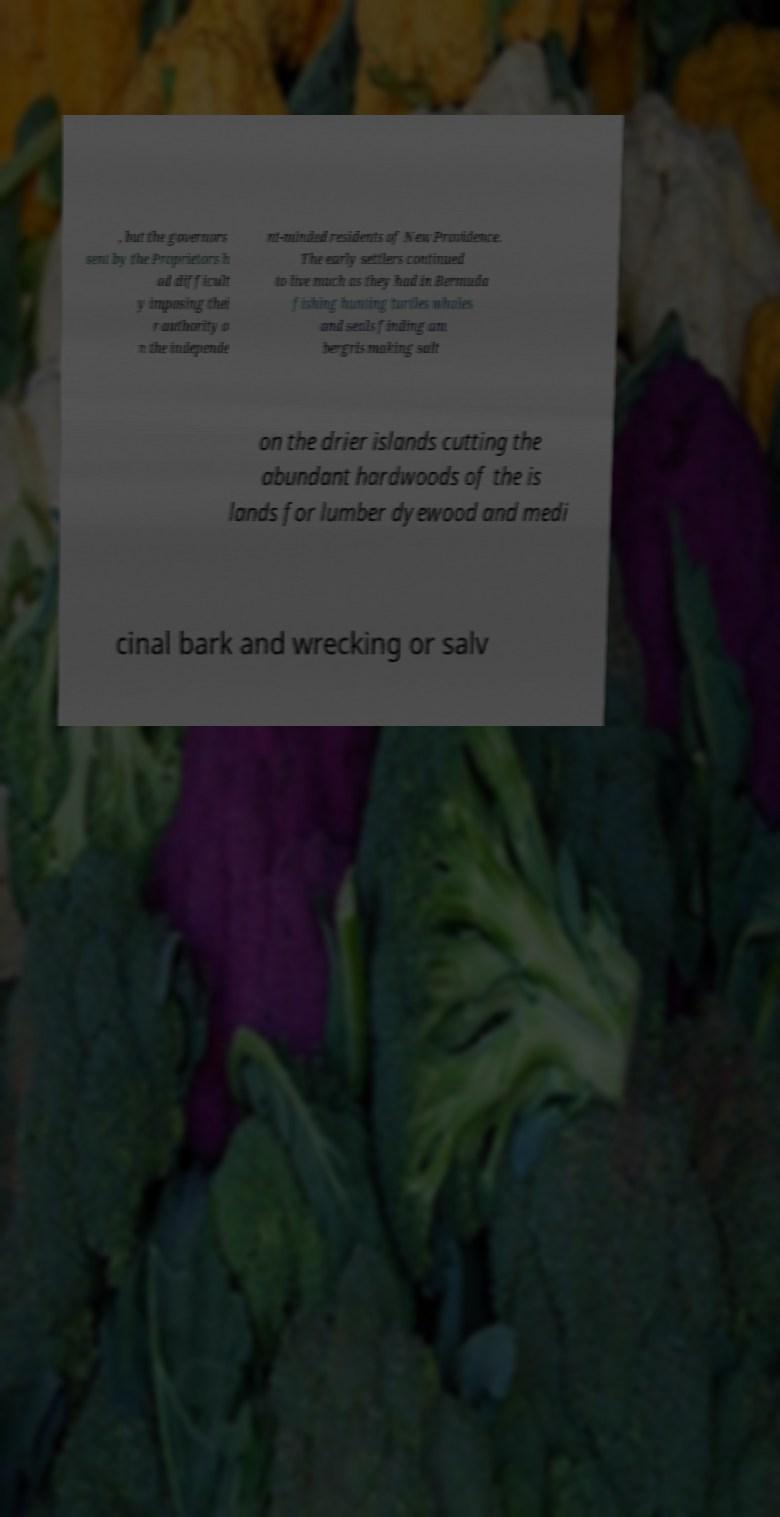Please read and relay the text visible in this image. What does it say? , but the governors sent by the Proprietors h ad difficult y imposing thei r authority o n the independe nt-minded residents of New Providence. The early settlers continued to live much as they had in Bermuda fishing hunting turtles whales and seals finding am bergris making salt on the drier islands cutting the abundant hardwoods of the is lands for lumber dyewood and medi cinal bark and wrecking or salv 